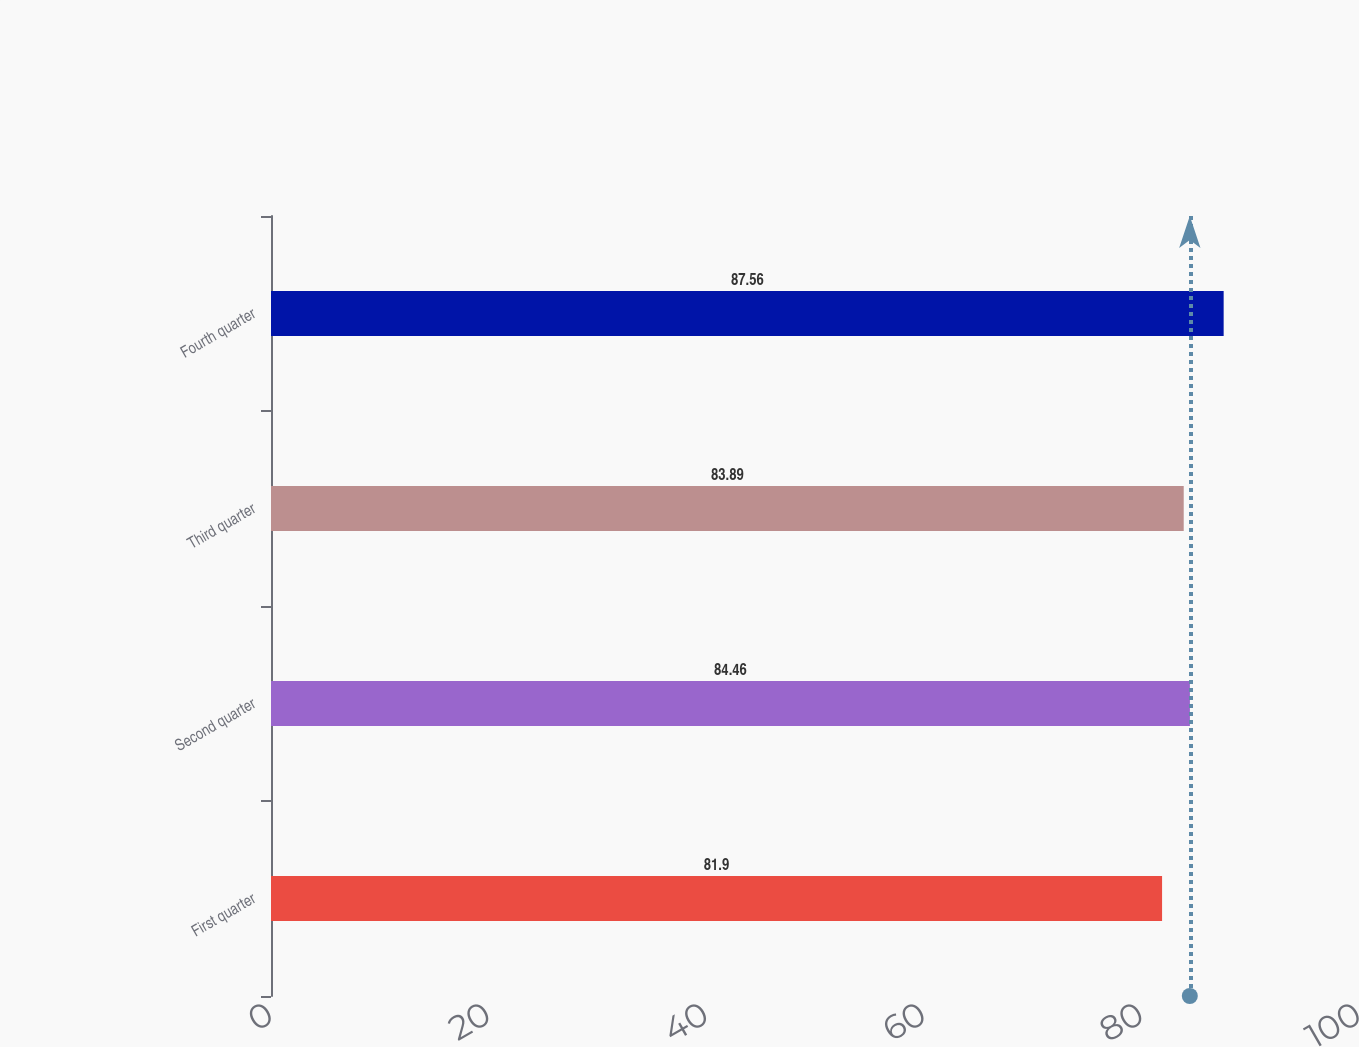Convert chart. <chart><loc_0><loc_0><loc_500><loc_500><bar_chart><fcel>First quarter<fcel>Second quarter<fcel>Third quarter<fcel>Fourth quarter<nl><fcel>81.9<fcel>84.46<fcel>83.89<fcel>87.56<nl></chart> 